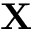<formula> <loc_0><loc_0><loc_500><loc_500>X</formula> 